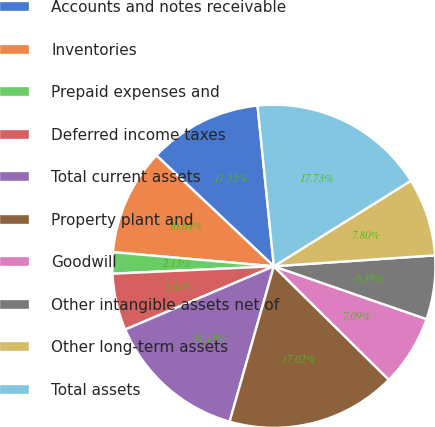Convert chart. <chart><loc_0><loc_0><loc_500><loc_500><pie_chart><fcel>Accounts and notes receivable<fcel>Inventories<fcel>Prepaid expenses and<fcel>Deferred income taxes<fcel>Total current assets<fcel>Property plant and<fcel>Goodwill<fcel>Other intangible assets net of<fcel>Other long-term assets<fcel>Total assets<nl><fcel>11.35%<fcel>10.64%<fcel>2.13%<fcel>5.67%<fcel>14.18%<fcel>17.02%<fcel>7.09%<fcel>6.38%<fcel>7.8%<fcel>17.73%<nl></chart> 